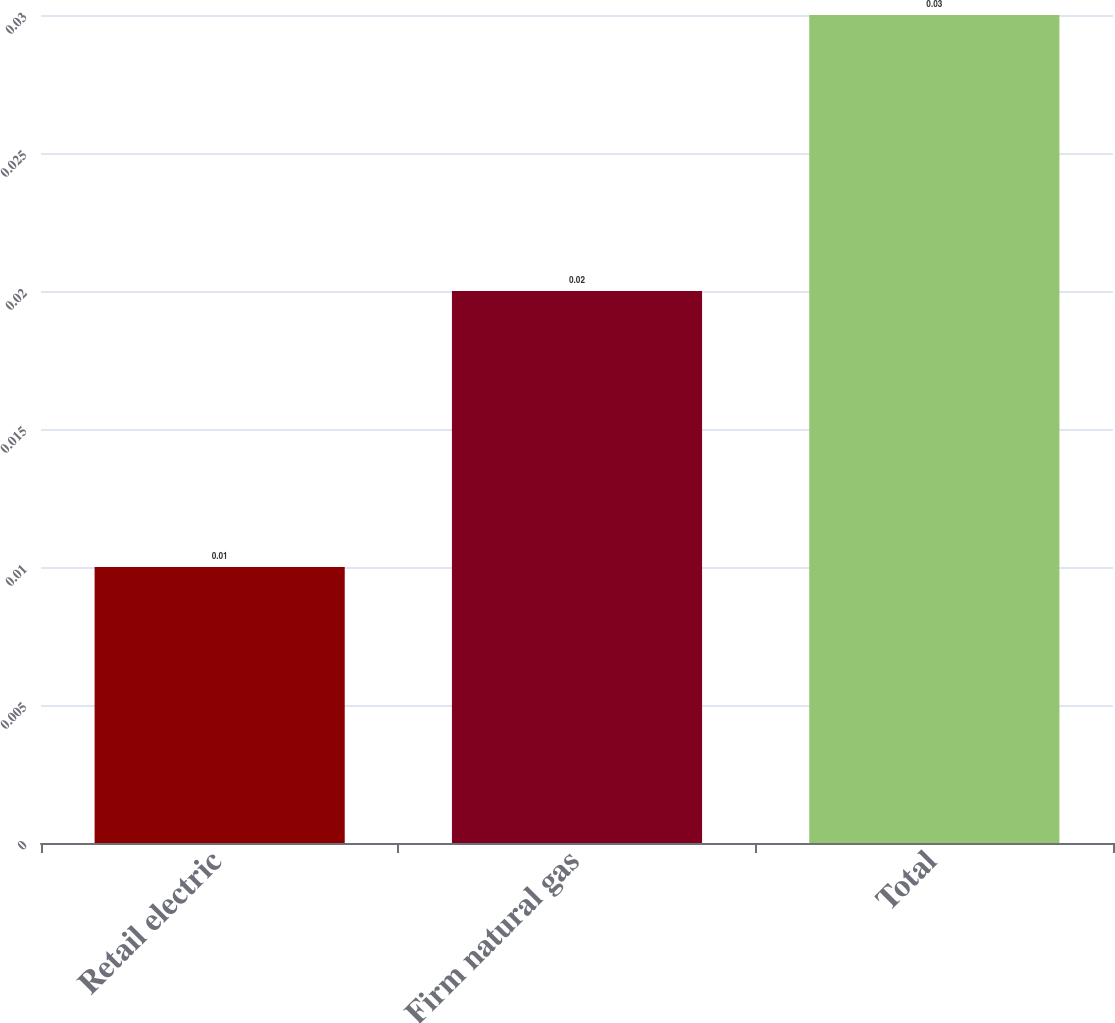Convert chart to OTSL. <chart><loc_0><loc_0><loc_500><loc_500><bar_chart><fcel>Retail electric<fcel>Firm natural gas<fcel>Total<nl><fcel>0.01<fcel>0.02<fcel>0.03<nl></chart> 